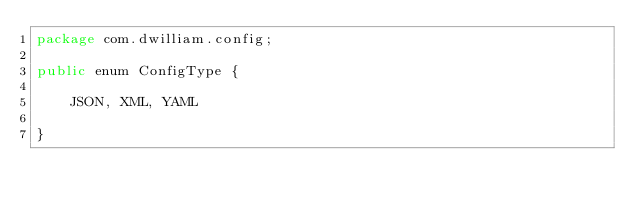Convert code to text. <code><loc_0><loc_0><loc_500><loc_500><_Java_>package com.dwilliam.config;

public enum ConfigType {

    JSON, XML, YAML

}
</code> 